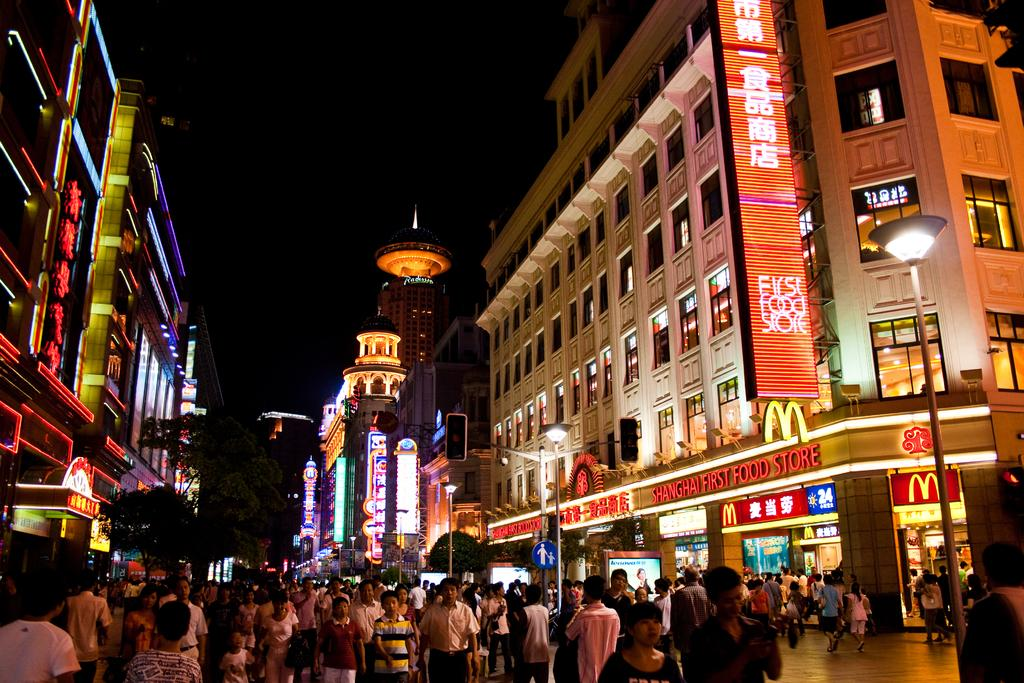Who or what can be seen in the image? There are people in the image. What objects are present in the image? There are poles, lights, boards, trees, hoardings, and buildings in the image. Can you describe the lighting conditions in the image? The background of the image is dark. What type of spoon can be seen being used as a reward in the image? There is no spoon present in the image, nor is there any indication of a reward being given. 